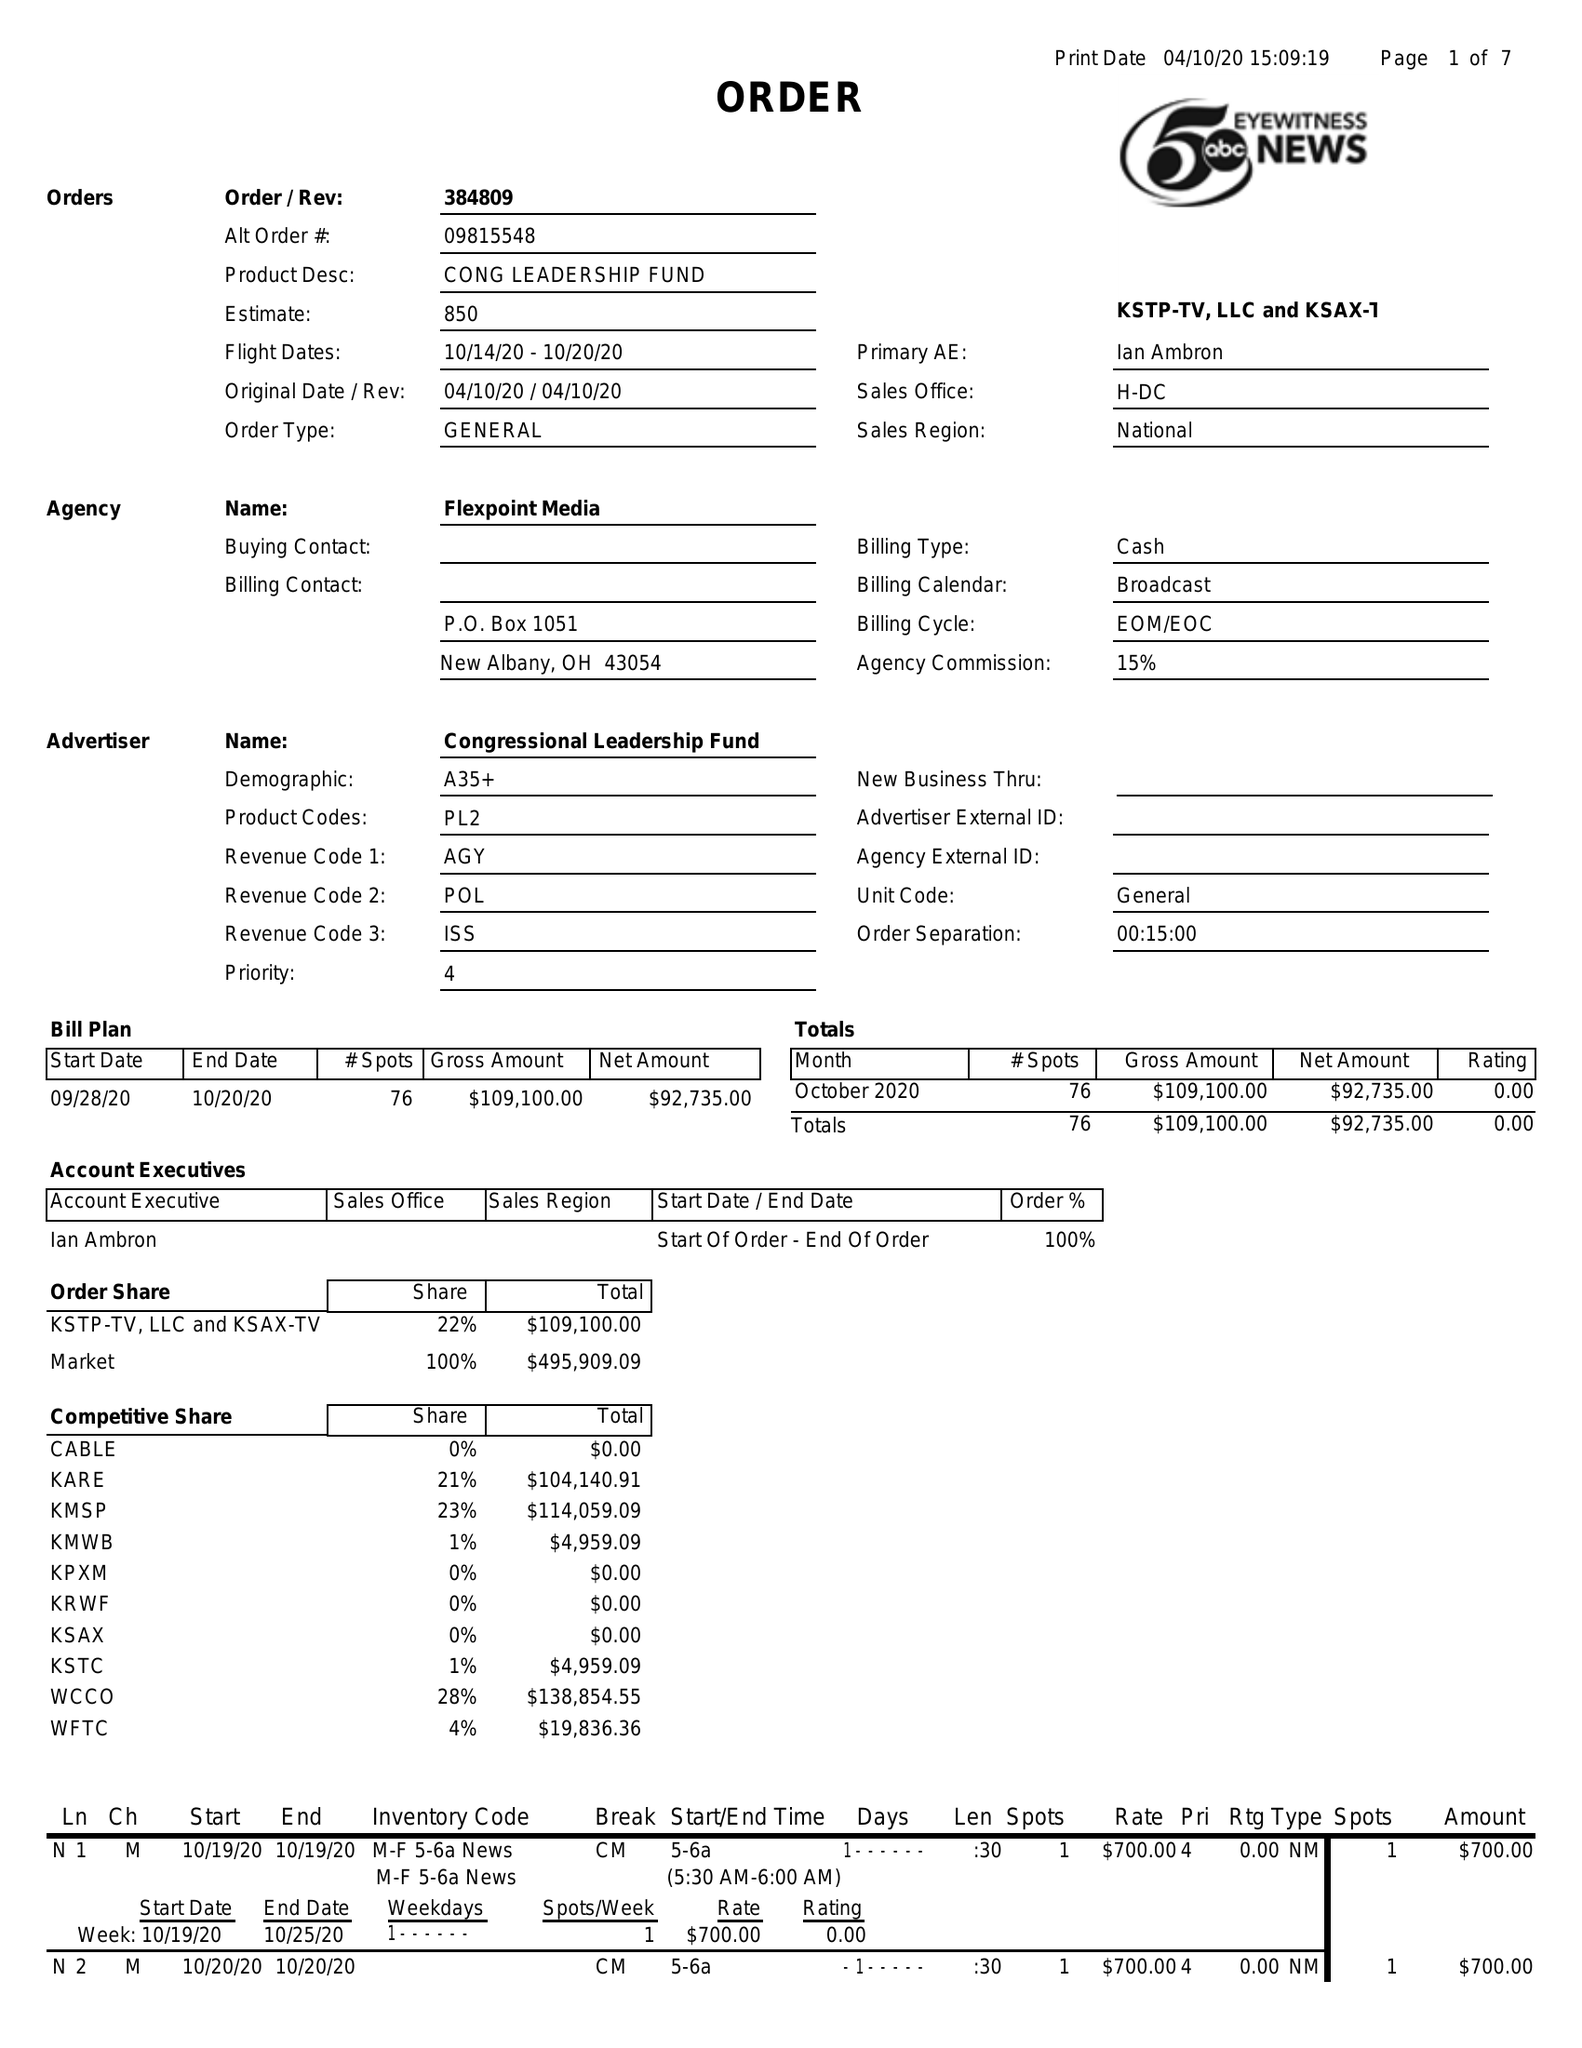What is the value for the flight_to?
Answer the question using a single word or phrase. 10/20/20 